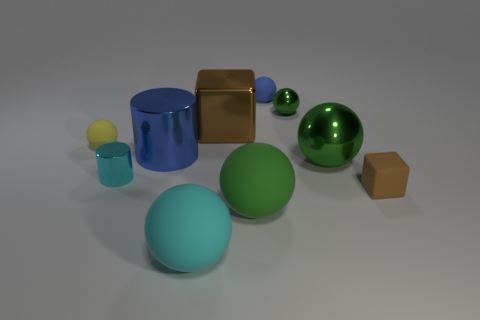There is a blue matte thing that is the same shape as the yellow matte thing; what size is it?
Keep it short and to the point. Small. What material is the green thing that is in front of the small matte thing that is in front of the large green thing behind the brown rubber thing?
Provide a succinct answer. Rubber. Is the number of cyan balls on the right side of the large cyan rubber thing greater than the number of large blue metal cylinders behind the small brown matte thing?
Your response must be concise. No. Is the cyan matte sphere the same size as the brown metal thing?
Offer a very short reply. Yes. What color is the other small rubber thing that is the same shape as the yellow thing?
Provide a short and direct response. Blue. How many objects have the same color as the large cylinder?
Provide a short and direct response. 1. Is the number of metallic things to the left of the large blue thing greater than the number of small brown metal cylinders?
Keep it short and to the point. Yes. There is a metallic ball in front of the rubber object left of the large blue metal cylinder; what color is it?
Your answer should be very brief. Green. What number of objects are green balls that are in front of the tiny brown matte thing or things right of the large green matte thing?
Ensure brevity in your answer.  5. The big metallic cube is what color?
Your answer should be very brief. Brown. 